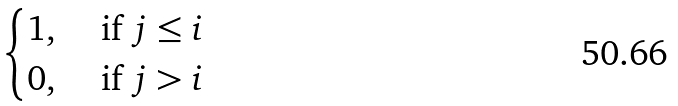Convert formula to latex. <formula><loc_0><loc_0><loc_500><loc_500>\begin{cases} 1 , & \text { if } j \leq i \\ 0 , & \text { if } j > i \end{cases}</formula> 